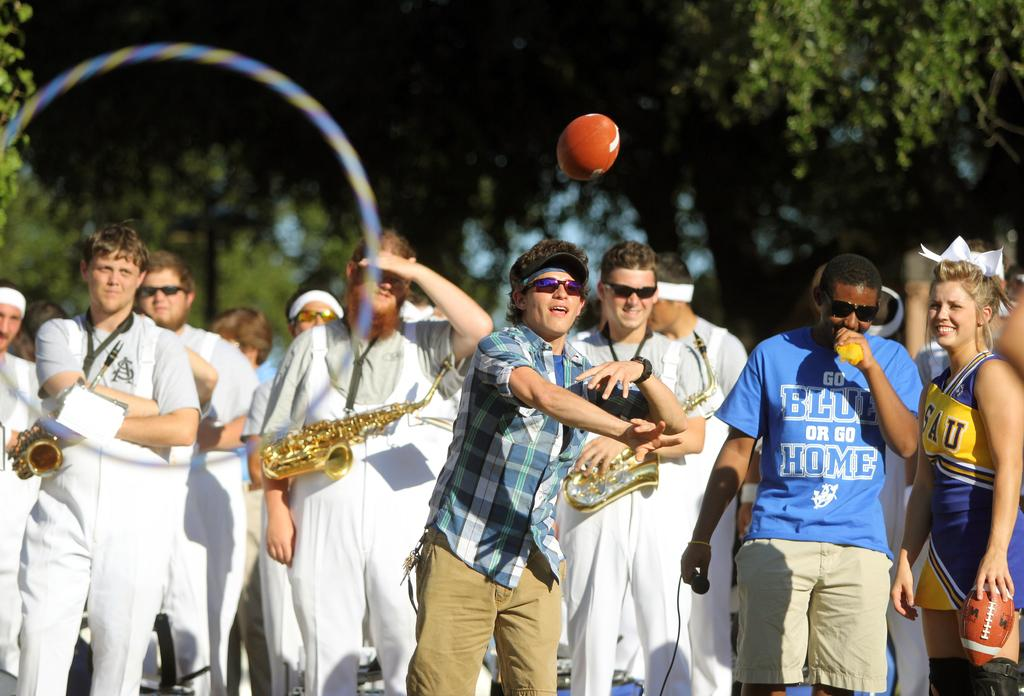<image>
Give a short and clear explanation of the subsequent image. the man next to the band has tshirt saying go blue or go home 